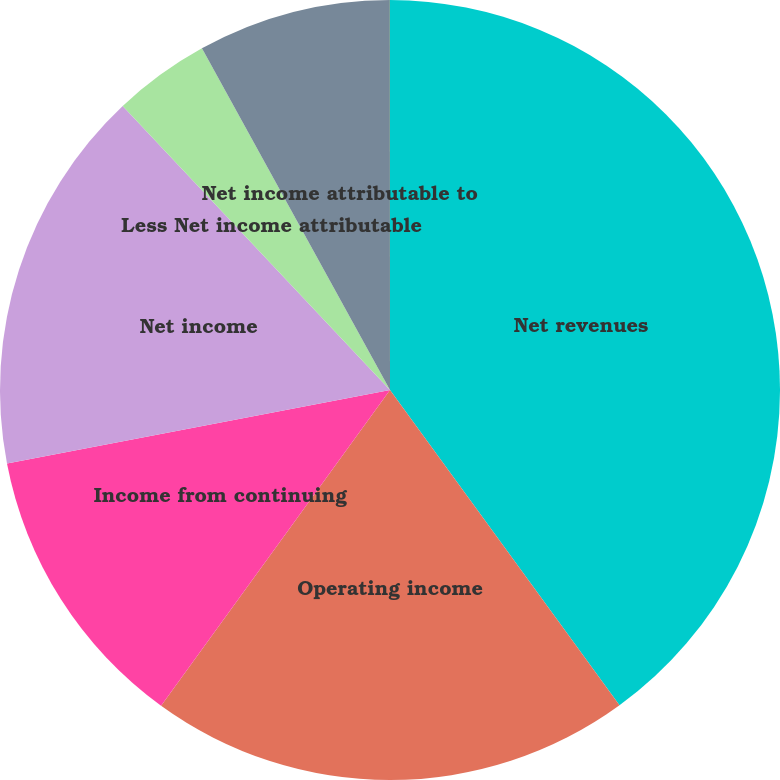Convert chart. <chart><loc_0><loc_0><loc_500><loc_500><pie_chart><fcel>Net revenues<fcel>Operating income<fcel>Income from continuing<fcel>Net income<fcel>Less Net income attributable<fcel>Net income attributable to<fcel>Dividends per common share<nl><fcel>39.99%<fcel>20.0%<fcel>12.0%<fcel>16.0%<fcel>4.01%<fcel>8.0%<fcel>0.01%<nl></chart> 